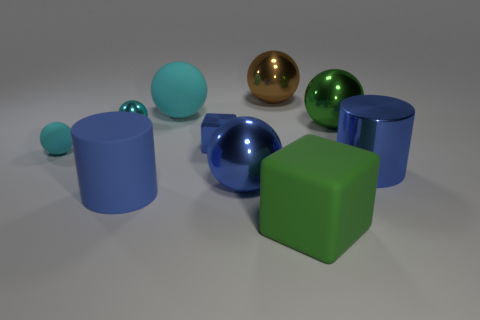Are the large blue cylinder left of the big brown shiny sphere and the green sphere made of the same material?
Your answer should be compact. No. What number of metal spheres are both behind the small blue object and in front of the big green shiny sphere?
Keep it short and to the point. 1. How many large green balls have the same material as the brown object?
Offer a terse response. 1. There is a large sphere that is made of the same material as the large block; what color is it?
Ensure brevity in your answer.  Cyan. Are there fewer big green balls than cyan matte objects?
Your answer should be compact. Yes. What is the material of the large cylinder that is right of the large cyan object to the right of the small cyan ball behind the tiny matte object?
Offer a very short reply. Metal. What is the green cube made of?
Your answer should be compact. Rubber. Is the color of the matte sphere that is in front of the small blue metal cube the same as the big cylinder on the right side of the brown shiny thing?
Provide a succinct answer. No. Are there more big spheres than tiny blue metallic things?
Give a very brief answer. Yes. What number of other cubes have the same color as the metal block?
Give a very brief answer. 0. 